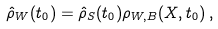Convert formula to latex. <formula><loc_0><loc_0><loc_500><loc_500>\hat { \rho } _ { W } ( t _ { 0 } ) = \hat { \rho } _ { S } ( t _ { 0 } ) \rho _ { W , B } ( X , t _ { 0 } ) \, ,</formula> 